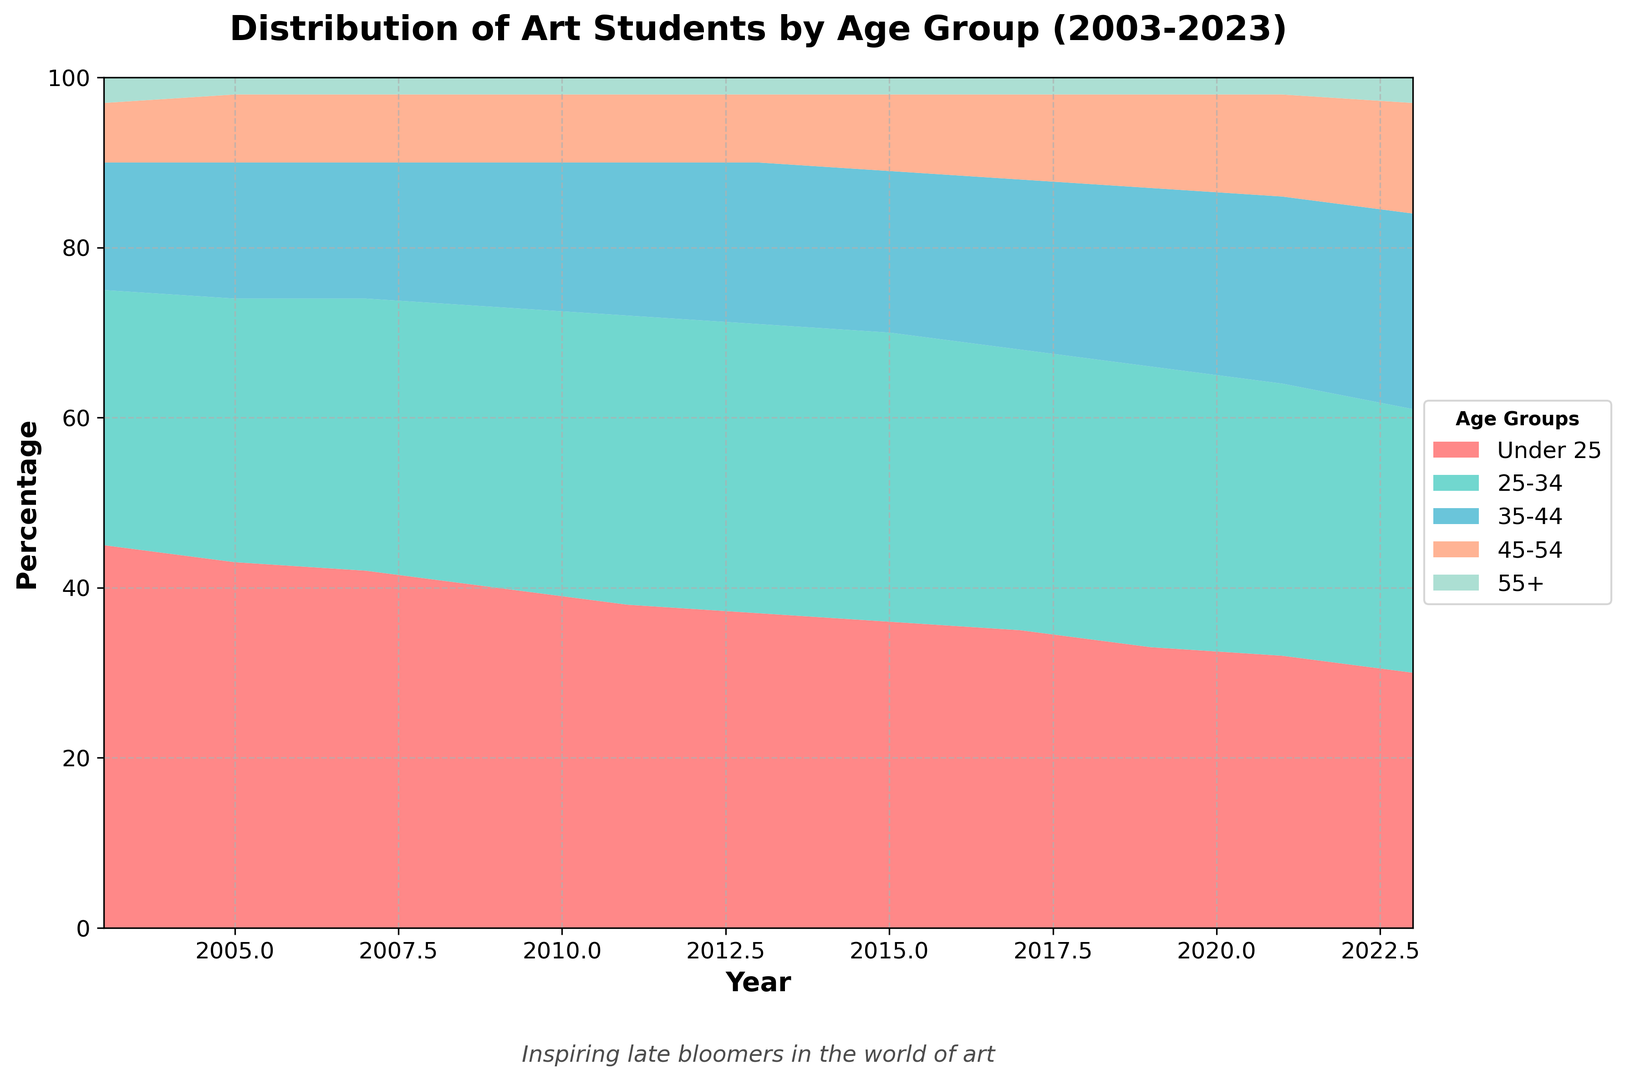What is the general trend of the percentage of students aged under 25 over the years? Analyze the height of the under 25 area from 2003 to 2023. Observe that it decreases steadily over the years. Specifically, it starts at 45% in 2003 and drops to 30% in 2023.
Answer: Decreasing What age group had the highest percentage in the year 2021? In 2021, examine the different colored sections and their heights. The 32% section (colored in red) representing the 25-34 age group is the highest.
Answer: 25-34 How did the percentage of students aged 45-54 change from 2003 to 2023? In 2003, the percentage is 7%, while in 2023 it increases to 13%. Calculate the difference: 13% - 7% = 6%, hence the percentage rose by 6%.
Answer: Increased by 6% Between which years did the percentage of students aged 35-44 remain constant? Look at the line representing 35-44. It stays at 34% from 2011 to 2015 without rising or falling.
Answer: 2011 to 2015 In which year did the percentage of students aged 55+ show a change from the previous year? Compare the values for the 55+ group (colored in green) for consecutive years. Notably, the percentage changed from 2% in 2021 to 3% in 2023.
Answer: 2023 What can you say about the percentage change in the 25-34 age group from 2003 to 2011? The percentage starts at 30% in 2003 and increases to 34% in 2011. Therefore, it increased by 4%.
Answer: Increased by 4% How does the composition of students aged under 25 compare between 2003 and 2023? In 2003, the under 25 group constitutes 45%, which declines to 30% by 2023.
Answer: Decreased by 15% Which age group showed the least fluctuation in percentage over the years? Observe the stability of each group's area height throughout the years. The 55+ group fluctuates the least, remaining around 2-3%.
Answer: 55+ By how much did the percentage of students aged 35-44 change from 2019 to 2023? The percentage increased from 21% in 2019 to 23% in 2023. Thus, the change is 23% - 21% = 2%.
Answer: Increased by 2% What trend is observed for the 45-54 age group between 2017 and 2023? The age group 45-54 shows a steady increase, from 10% in 2017 to 13% in 2023.
Answer: Increasing 